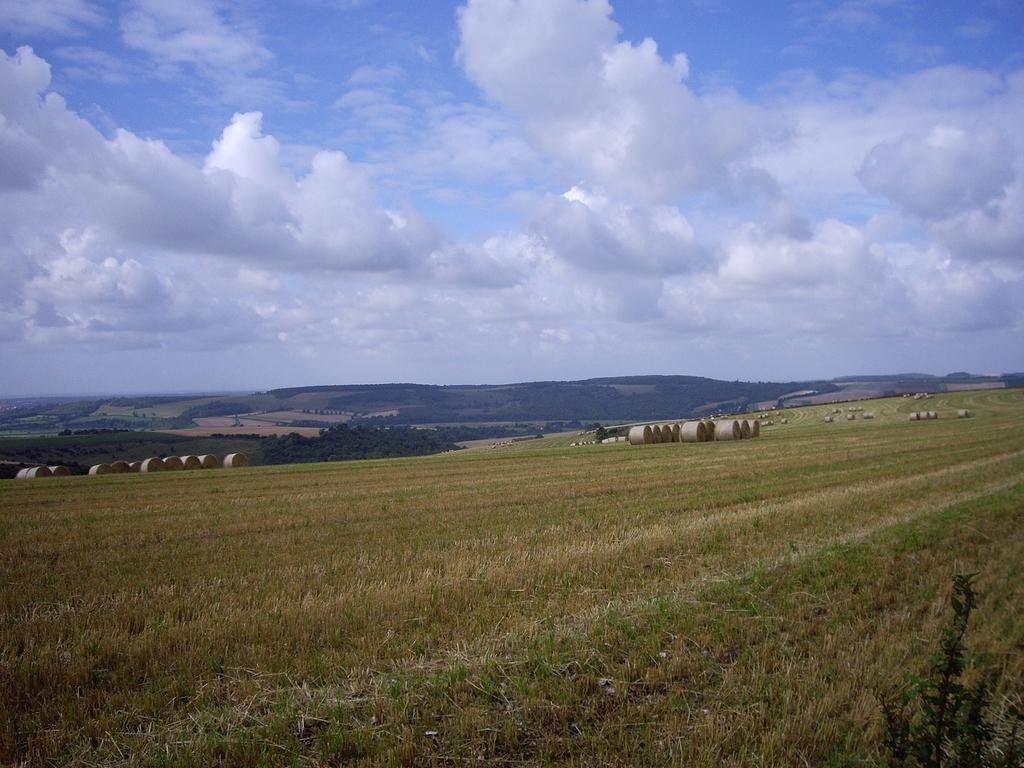What type of landscape is depicted in the image? There is a field in the image. What can be found in the field? There are grass bundles in the field. What is visible in the distance in the image? There are mountains in the background of the image. How would you describe the sky in the image? The sky is cloudy in the background of the image. How many wishes can be granted by the drawer in the image? There is no drawer present in the image, so it is not possible to grant any wishes. 